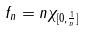<formula> <loc_0><loc_0><loc_500><loc_500>f _ { n } = n \chi _ { [ 0 , \frac { 1 } { n } ] }</formula> 